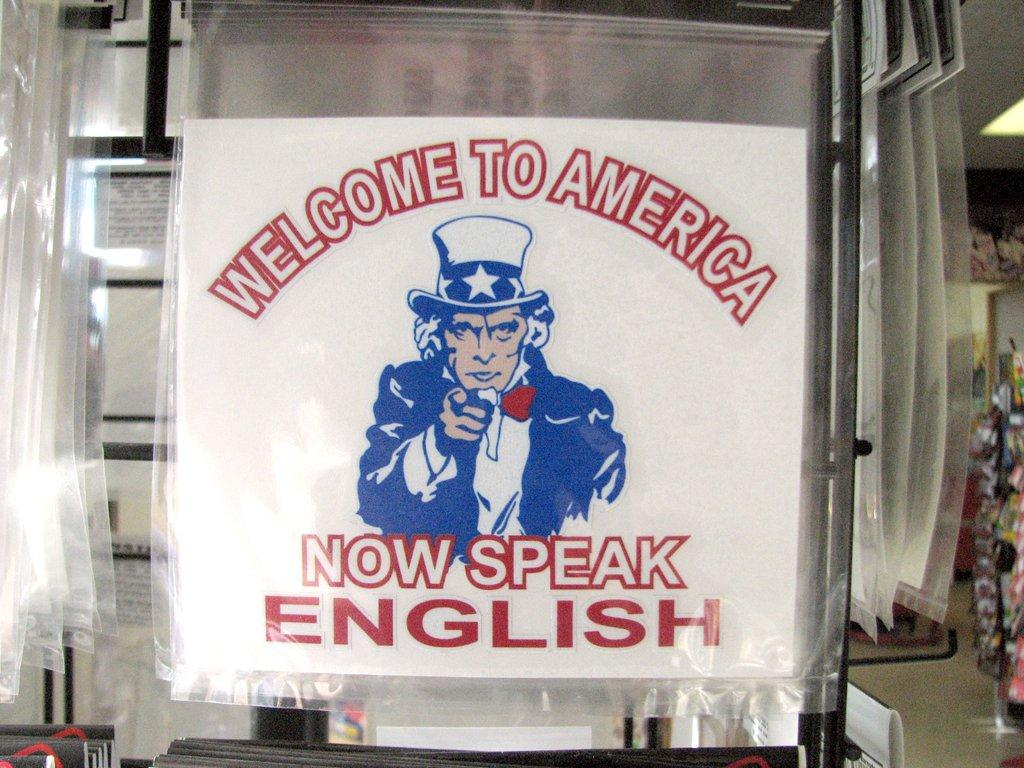<image>
Summarize the visual content of the image. A poster reading Come to America telling people to speak English. 